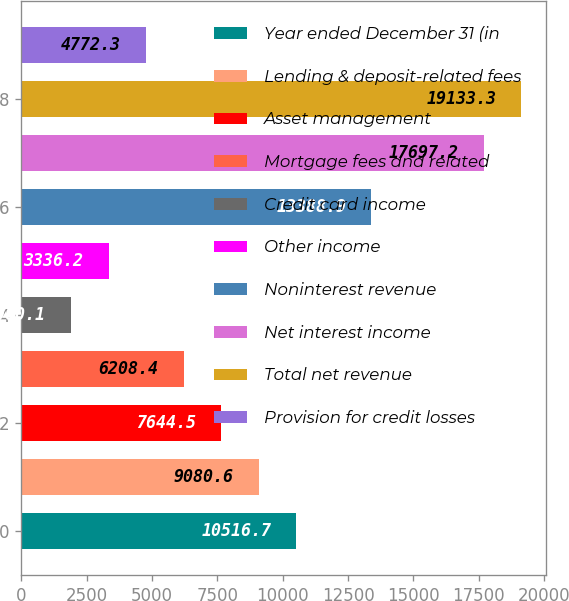Convert chart. <chart><loc_0><loc_0><loc_500><loc_500><bar_chart><fcel>Year ended December 31 (in<fcel>Lending & deposit-related fees<fcel>Asset management<fcel>Mortgage fees and related<fcel>Credit card income<fcel>Other income<fcel>Noninterest revenue<fcel>Net interest income<fcel>Total net revenue<fcel>Provision for credit losses<nl><fcel>10516.7<fcel>9080.6<fcel>7644.5<fcel>6208.4<fcel>1900.1<fcel>3336.2<fcel>13388.9<fcel>17697.2<fcel>19133.3<fcel>4772.3<nl></chart> 